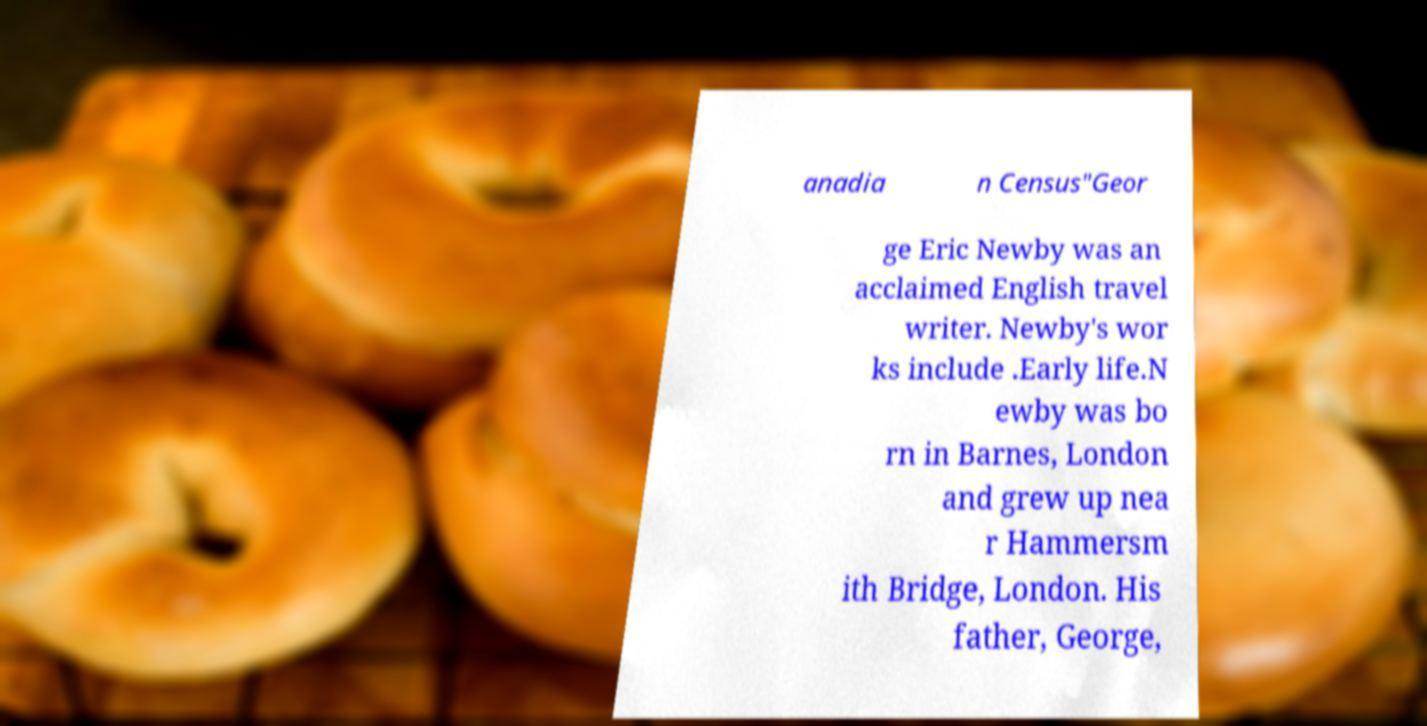Could you assist in decoding the text presented in this image and type it out clearly? anadia n Census"Geor ge Eric Newby was an acclaimed English travel writer. Newby's wor ks include .Early life.N ewby was bo rn in Barnes, London and grew up nea r Hammersm ith Bridge, London. His father, George, 